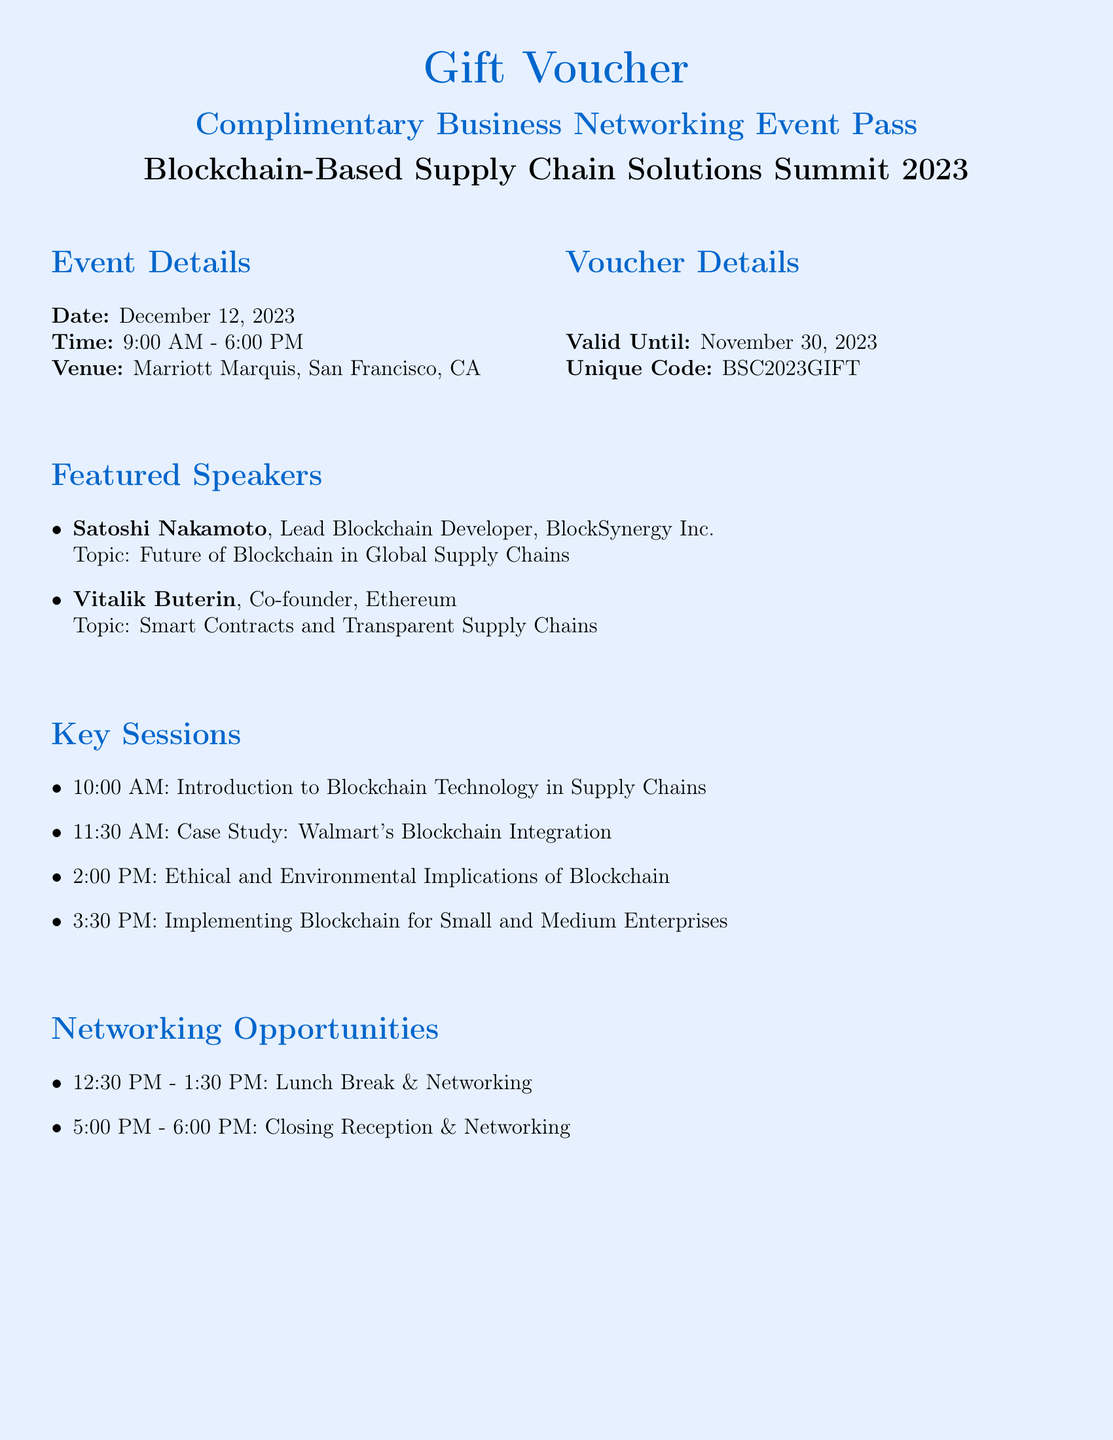What is the event date? The event date is clearly stated in the details section of the document.
Answer: December 12, 2023 What is the time of the event? The time is mentioned alongside the date in the event details.
Answer: 9:00 AM - 6:00 PM Where is the event taking place? The venue is specified in the event details section.
Answer: Marriott Marquis, San Francisco, CA What is the unique code for the voucher? This code is listed under the voucher details section of the document.
Answer: BSC2023GIFT Who is one of the featured speakers? The list of featured speakers includes prominent figures mentioned in the document.
Answer: Satoshi Nakamoto What is one key session topic? Several key session topics are listed, demonstrating the focus of the event.
Answer: Introduction to Blockchain Technology in Supply Chains What is the networking time during lunch? The networking opportunity occurs at a specific time, mentioned in the document.
Answer: 12:30 PM - 1:30 PM Until when is the voucher valid? The validity period of the voucher is outlined in the voucher details section.
Answer: November 30, 2023 Who is the message intended for? The personalized message section indicates a specific recipient.
Answer: [Recipient Name] 